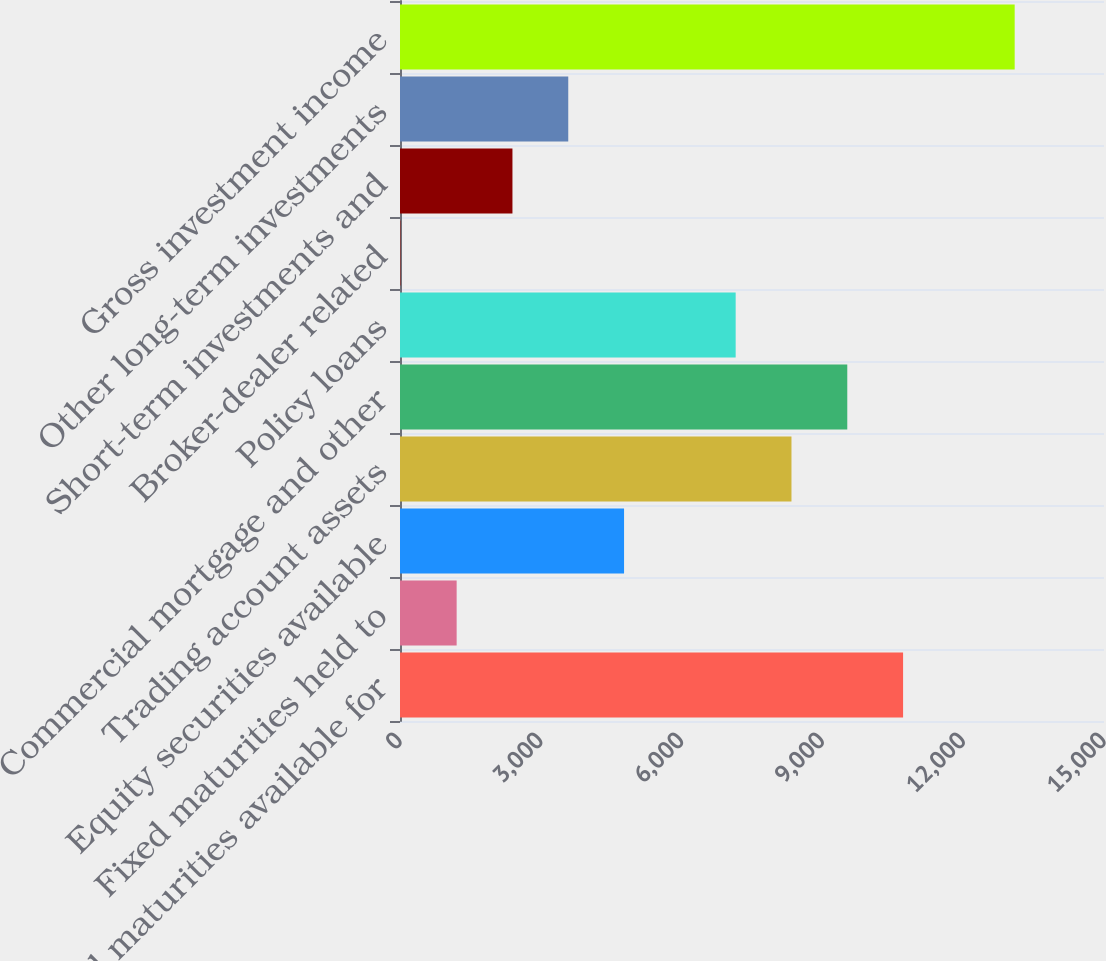Convert chart. <chart><loc_0><loc_0><loc_500><loc_500><bar_chart><fcel>Fixed maturities available for<fcel>Fixed maturities held to<fcel>Equity securities available<fcel>Trading account assets<fcel>Commercial mortgage and other<fcel>Policy loans<fcel>Broker-dealer related<fcel>Short-term investments and<fcel>Other long-term investments<fcel>Gross investment income<nl><fcel>10719<fcel>1207<fcel>4774<fcel>8341<fcel>9530<fcel>7152<fcel>18<fcel>2396<fcel>3585<fcel>13097<nl></chart> 